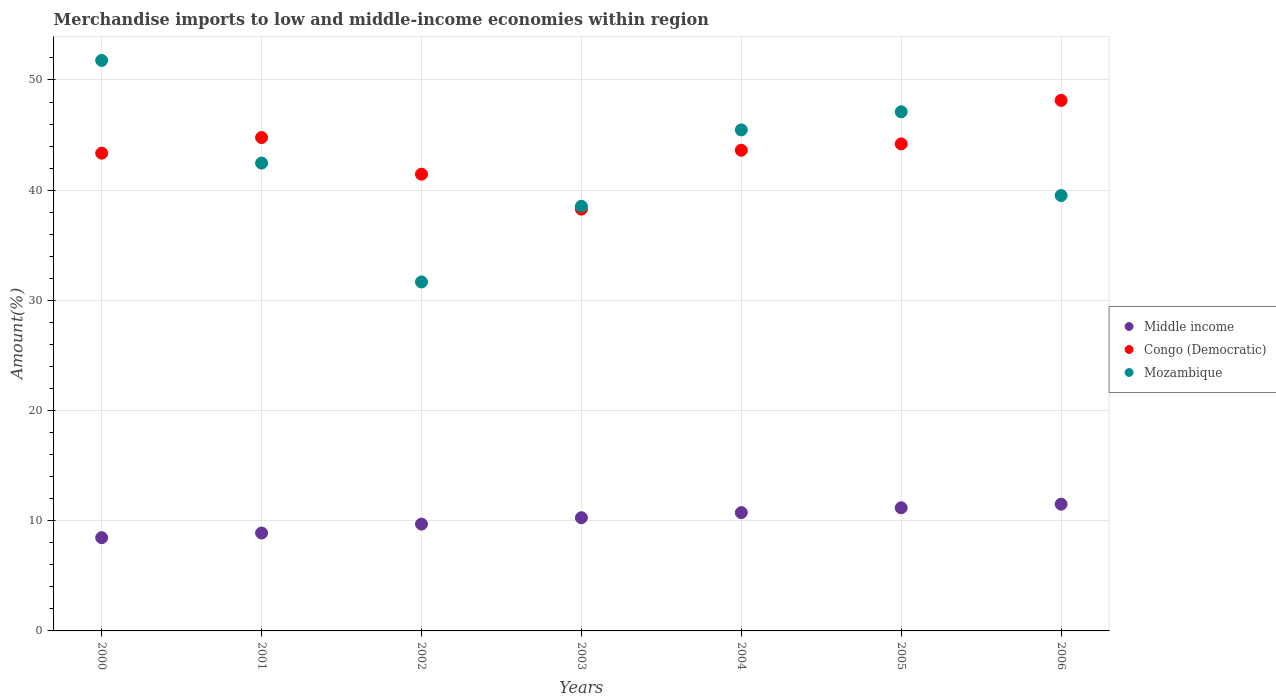How many different coloured dotlines are there?
Offer a very short reply. 3. What is the percentage of amount earned from merchandise imports in Mozambique in 2002?
Provide a short and direct response. 31.67. Across all years, what is the maximum percentage of amount earned from merchandise imports in Congo (Democratic)?
Provide a short and direct response. 48.15. Across all years, what is the minimum percentage of amount earned from merchandise imports in Mozambique?
Provide a short and direct response. 31.67. In which year was the percentage of amount earned from merchandise imports in Middle income maximum?
Give a very brief answer. 2006. In which year was the percentage of amount earned from merchandise imports in Mozambique minimum?
Ensure brevity in your answer.  2002. What is the total percentage of amount earned from merchandise imports in Mozambique in the graph?
Ensure brevity in your answer.  296.53. What is the difference between the percentage of amount earned from merchandise imports in Congo (Democratic) in 2002 and that in 2006?
Provide a short and direct response. -6.7. What is the difference between the percentage of amount earned from merchandise imports in Mozambique in 2006 and the percentage of amount earned from merchandise imports in Congo (Democratic) in 2002?
Your response must be concise. -1.94. What is the average percentage of amount earned from merchandise imports in Congo (Democratic) per year?
Keep it short and to the point. 43.4. In the year 2005, what is the difference between the percentage of amount earned from merchandise imports in Middle income and percentage of amount earned from merchandise imports in Congo (Democratic)?
Offer a terse response. -33.02. What is the ratio of the percentage of amount earned from merchandise imports in Mozambique in 2003 to that in 2005?
Offer a very short reply. 0.82. What is the difference between the highest and the second highest percentage of amount earned from merchandise imports in Mozambique?
Offer a very short reply. 4.66. What is the difference between the highest and the lowest percentage of amount earned from merchandise imports in Congo (Democratic)?
Your answer should be compact. 9.87. In how many years, is the percentage of amount earned from merchandise imports in Congo (Democratic) greater than the average percentage of amount earned from merchandise imports in Congo (Democratic) taken over all years?
Provide a succinct answer. 4. Is it the case that in every year, the sum of the percentage of amount earned from merchandise imports in Middle income and percentage of amount earned from merchandise imports in Mozambique  is greater than the percentage of amount earned from merchandise imports in Congo (Democratic)?
Give a very brief answer. No. Does the percentage of amount earned from merchandise imports in Congo (Democratic) monotonically increase over the years?
Your response must be concise. No. How many dotlines are there?
Ensure brevity in your answer.  3. Are the values on the major ticks of Y-axis written in scientific E-notation?
Keep it short and to the point. No. Does the graph contain grids?
Your response must be concise. Yes. Where does the legend appear in the graph?
Give a very brief answer. Center right. What is the title of the graph?
Your response must be concise. Merchandise imports to low and middle-income economies within region. Does "Grenada" appear as one of the legend labels in the graph?
Provide a short and direct response. No. What is the label or title of the X-axis?
Offer a very short reply. Years. What is the label or title of the Y-axis?
Your answer should be compact. Amount(%). What is the Amount(%) in Middle income in 2000?
Offer a very short reply. 8.46. What is the Amount(%) of Congo (Democratic) in 2000?
Make the answer very short. 43.36. What is the Amount(%) of Mozambique in 2000?
Offer a very short reply. 51.77. What is the Amount(%) of Middle income in 2001?
Make the answer very short. 8.89. What is the Amount(%) in Congo (Democratic) in 2001?
Your answer should be compact. 44.78. What is the Amount(%) in Mozambique in 2001?
Make the answer very short. 42.46. What is the Amount(%) of Middle income in 2002?
Keep it short and to the point. 9.69. What is the Amount(%) of Congo (Democratic) in 2002?
Provide a succinct answer. 41.45. What is the Amount(%) of Mozambique in 2002?
Offer a terse response. 31.67. What is the Amount(%) of Middle income in 2003?
Provide a short and direct response. 10.27. What is the Amount(%) of Congo (Democratic) in 2003?
Keep it short and to the point. 38.28. What is the Amount(%) in Mozambique in 2003?
Provide a short and direct response. 38.54. What is the Amount(%) in Middle income in 2004?
Provide a short and direct response. 10.74. What is the Amount(%) of Congo (Democratic) in 2004?
Your answer should be very brief. 43.62. What is the Amount(%) of Mozambique in 2004?
Ensure brevity in your answer.  45.47. What is the Amount(%) in Middle income in 2005?
Keep it short and to the point. 11.17. What is the Amount(%) of Congo (Democratic) in 2005?
Keep it short and to the point. 44.2. What is the Amount(%) of Mozambique in 2005?
Offer a terse response. 47.11. What is the Amount(%) in Middle income in 2006?
Your answer should be compact. 11.5. What is the Amount(%) in Congo (Democratic) in 2006?
Your answer should be very brief. 48.15. What is the Amount(%) in Mozambique in 2006?
Offer a very short reply. 39.51. Across all years, what is the maximum Amount(%) of Middle income?
Your answer should be very brief. 11.5. Across all years, what is the maximum Amount(%) of Congo (Democratic)?
Your response must be concise. 48.15. Across all years, what is the maximum Amount(%) of Mozambique?
Offer a very short reply. 51.77. Across all years, what is the minimum Amount(%) in Middle income?
Ensure brevity in your answer.  8.46. Across all years, what is the minimum Amount(%) in Congo (Democratic)?
Your answer should be very brief. 38.28. Across all years, what is the minimum Amount(%) in Mozambique?
Offer a terse response. 31.67. What is the total Amount(%) of Middle income in the graph?
Offer a very short reply. 70.73. What is the total Amount(%) in Congo (Democratic) in the graph?
Offer a terse response. 303.83. What is the total Amount(%) of Mozambique in the graph?
Provide a succinct answer. 296.53. What is the difference between the Amount(%) in Middle income in 2000 and that in 2001?
Your answer should be very brief. -0.42. What is the difference between the Amount(%) in Congo (Democratic) in 2000 and that in 2001?
Your response must be concise. -1.42. What is the difference between the Amount(%) in Mozambique in 2000 and that in 2001?
Offer a terse response. 9.32. What is the difference between the Amount(%) of Middle income in 2000 and that in 2002?
Your response must be concise. -1.23. What is the difference between the Amount(%) of Congo (Democratic) in 2000 and that in 2002?
Offer a terse response. 1.91. What is the difference between the Amount(%) of Mozambique in 2000 and that in 2002?
Provide a succinct answer. 20.1. What is the difference between the Amount(%) in Middle income in 2000 and that in 2003?
Offer a very short reply. -1.81. What is the difference between the Amount(%) in Congo (Democratic) in 2000 and that in 2003?
Provide a succinct answer. 5.08. What is the difference between the Amount(%) of Mozambique in 2000 and that in 2003?
Provide a short and direct response. 13.23. What is the difference between the Amount(%) in Middle income in 2000 and that in 2004?
Ensure brevity in your answer.  -2.28. What is the difference between the Amount(%) in Congo (Democratic) in 2000 and that in 2004?
Provide a short and direct response. -0.27. What is the difference between the Amount(%) of Mozambique in 2000 and that in 2004?
Your answer should be compact. 6.31. What is the difference between the Amount(%) of Middle income in 2000 and that in 2005?
Your response must be concise. -2.71. What is the difference between the Amount(%) of Congo (Democratic) in 2000 and that in 2005?
Provide a short and direct response. -0.84. What is the difference between the Amount(%) in Mozambique in 2000 and that in 2005?
Ensure brevity in your answer.  4.66. What is the difference between the Amount(%) in Middle income in 2000 and that in 2006?
Give a very brief answer. -3.04. What is the difference between the Amount(%) in Congo (Democratic) in 2000 and that in 2006?
Your response must be concise. -4.79. What is the difference between the Amount(%) in Mozambique in 2000 and that in 2006?
Offer a terse response. 12.26. What is the difference between the Amount(%) in Middle income in 2001 and that in 2002?
Your answer should be compact. -0.81. What is the difference between the Amount(%) of Congo (Democratic) in 2001 and that in 2002?
Provide a succinct answer. 3.32. What is the difference between the Amount(%) of Mozambique in 2001 and that in 2002?
Your response must be concise. 10.79. What is the difference between the Amount(%) of Middle income in 2001 and that in 2003?
Your answer should be very brief. -1.39. What is the difference between the Amount(%) in Congo (Democratic) in 2001 and that in 2003?
Give a very brief answer. 6.5. What is the difference between the Amount(%) in Mozambique in 2001 and that in 2003?
Offer a very short reply. 3.92. What is the difference between the Amount(%) of Middle income in 2001 and that in 2004?
Ensure brevity in your answer.  -1.85. What is the difference between the Amount(%) in Congo (Democratic) in 2001 and that in 2004?
Your response must be concise. 1.15. What is the difference between the Amount(%) of Mozambique in 2001 and that in 2004?
Give a very brief answer. -3.01. What is the difference between the Amount(%) in Middle income in 2001 and that in 2005?
Your answer should be compact. -2.29. What is the difference between the Amount(%) in Congo (Democratic) in 2001 and that in 2005?
Provide a succinct answer. 0.58. What is the difference between the Amount(%) in Mozambique in 2001 and that in 2005?
Ensure brevity in your answer.  -4.66. What is the difference between the Amount(%) in Middle income in 2001 and that in 2006?
Provide a short and direct response. -2.62. What is the difference between the Amount(%) of Congo (Democratic) in 2001 and that in 2006?
Offer a terse response. -3.37. What is the difference between the Amount(%) of Mozambique in 2001 and that in 2006?
Your response must be concise. 2.94. What is the difference between the Amount(%) in Middle income in 2002 and that in 2003?
Give a very brief answer. -0.58. What is the difference between the Amount(%) of Congo (Democratic) in 2002 and that in 2003?
Your response must be concise. 3.17. What is the difference between the Amount(%) in Mozambique in 2002 and that in 2003?
Your response must be concise. -6.87. What is the difference between the Amount(%) of Middle income in 2002 and that in 2004?
Ensure brevity in your answer.  -1.04. What is the difference between the Amount(%) of Congo (Democratic) in 2002 and that in 2004?
Provide a succinct answer. -2.17. What is the difference between the Amount(%) in Mozambique in 2002 and that in 2004?
Your answer should be very brief. -13.8. What is the difference between the Amount(%) in Middle income in 2002 and that in 2005?
Your response must be concise. -1.48. What is the difference between the Amount(%) in Congo (Democratic) in 2002 and that in 2005?
Offer a terse response. -2.75. What is the difference between the Amount(%) of Mozambique in 2002 and that in 2005?
Offer a very short reply. -15.44. What is the difference between the Amount(%) in Middle income in 2002 and that in 2006?
Ensure brevity in your answer.  -1.81. What is the difference between the Amount(%) in Congo (Democratic) in 2002 and that in 2006?
Keep it short and to the point. -6.7. What is the difference between the Amount(%) of Mozambique in 2002 and that in 2006?
Ensure brevity in your answer.  -7.84. What is the difference between the Amount(%) of Middle income in 2003 and that in 2004?
Provide a succinct answer. -0.46. What is the difference between the Amount(%) of Congo (Democratic) in 2003 and that in 2004?
Make the answer very short. -5.34. What is the difference between the Amount(%) in Mozambique in 2003 and that in 2004?
Offer a terse response. -6.93. What is the difference between the Amount(%) of Middle income in 2003 and that in 2005?
Make the answer very short. -0.9. What is the difference between the Amount(%) in Congo (Democratic) in 2003 and that in 2005?
Your answer should be very brief. -5.92. What is the difference between the Amount(%) of Mozambique in 2003 and that in 2005?
Your answer should be compact. -8.57. What is the difference between the Amount(%) in Middle income in 2003 and that in 2006?
Offer a very short reply. -1.23. What is the difference between the Amount(%) of Congo (Democratic) in 2003 and that in 2006?
Your answer should be compact. -9.87. What is the difference between the Amount(%) of Mozambique in 2003 and that in 2006?
Make the answer very short. -0.98. What is the difference between the Amount(%) in Middle income in 2004 and that in 2005?
Offer a very short reply. -0.44. What is the difference between the Amount(%) of Congo (Democratic) in 2004 and that in 2005?
Provide a short and direct response. -0.57. What is the difference between the Amount(%) of Mozambique in 2004 and that in 2005?
Ensure brevity in your answer.  -1.65. What is the difference between the Amount(%) in Middle income in 2004 and that in 2006?
Give a very brief answer. -0.76. What is the difference between the Amount(%) in Congo (Democratic) in 2004 and that in 2006?
Offer a terse response. -4.52. What is the difference between the Amount(%) of Mozambique in 2004 and that in 2006?
Your answer should be very brief. 5.95. What is the difference between the Amount(%) of Middle income in 2005 and that in 2006?
Provide a succinct answer. -0.33. What is the difference between the Amount(%) of Congo (Democratic) in 2005 and that in 2006?
Make the answer very short. -3.95. What is the difference between the Amount(%) of Mozambique in 2005 and that in 2006?
Your response must be concise. 7.6. What is the difference between the Amount(%) in Middle income in 2000 and the Amount(%) in Congo (Democratic) in 2001?
Provide a succinct answer. -36.31. What is the difference between the Amount(%) of Middle income in 2000 and the Amount(%) of Mozambique in 2001?
Your response must be concise. -33.99. What is the difference between the Amount(%) of Congo (Democratic) in 2000 and the Amount(%) of Mozambique in 2001?
Offer a terse response. 0.9. What is the difference between the Amount(%) in Middle income in 2000 and the Amount(%) in Congo (Democratic) in 2002?
Offer a very short reply. -32.99. What is the difference between the Amount(%) of Middle income in 2000 and the Amount(%) of Mozambique in 2002?
Ensure brevity in your answer.  -23.21. What is the difference between the Amount(%) of Congo (Democratic) in 2000 and the Amount(%) of Mozambique in 2002?
Ensure brevity in your answer.  11.69. What is the difference between the Amount(%) of Middle income in 2000 and the Amount(%) of Congo (Democratic) in 2003?
Your answer should be very brief. -29.82. What is the difference between the Amount(%) of Middle income in 2000 and the Amount(%) of Mozambique in 2003?
Make the answer very short. -30.08. What is the difference between the Amount(%) of Congo (Democratic) in 2000 and the Amount(%) of Mozambique in 2003?
Provide a succinct answer. 4.82. What is the difference between the Amount(%) in Middle income in 2000 and the Amount(%) in Congo (Democratic) in 2004?
Keep it short and to the point. -35.16. What is the difference between the Amount(%) of Middle income in 2000 and the Amount(%) of Mozambique in 2004?
Ensure brevity in your answer.  -37. What is the difference between the Amount(%) in Congo (Democratic) in 2000 and the Amount(%) in Mozambique in 2004?
Your answer should be very brief. -2.11. What is the difference between the Amount(%) of Middle income in 2000 and the Amount(%) of Congo (Democratic) in 2005?
Make the answer very short. -35.74. What is the difference between the Amount(%) of Middle income in 2000 and the Amount(%) of Mozambique in 2005?
Your answer should be very brief. -38.65. What is the difference between the Amount(%) of Congo (Democratic) in 2000 and the Amount(%) of Mozambique in 2005?
Provide a short and direct response. -3.76. What is the difference between the Amount(%) in Middle income in 2000 and the Amount(%) in Congo (Democratic) in 2006?
Ensure brevity in your answer.  -39.69. What is the difference between the Amount(%) of Middle income in 2000 and the Amount(%) of Mozambique in 2006?
Your answer should be compact. -31.05. What is the difference between the Amount(%) in Congo (Democratic) in 2000 and the Amount(%) in Mozambique in 2006?
Provide a short and direct response. 3.84. What is the difference between the Amount(%) of Middle income in 2001 and the Amount(%) of Congo (Democratic) in 2002?
Make the answer very short. -32.56. What is the difference between the Amount(%) of Middle income in 2001 and the Amount(%) of Mozambique in 2002?
Provide a short and direct response. -22.78. What is the difference between the Amount(%) in Congo (Democratic) in 2001 and the Amount(%) in Mozambique in 2002?
Your answer should be compact. 13.11. What is the difference between the Amount(%) of Middle income in 2001 and the Amount(%) of Congo (Democratic) in 2003?
Ensure brevity in your answer.  -29.39. What is the difference between the Amount(%) in Middle income in 2001 and the Amount(%) in Mozambique in 2003?
Provide a short and direct response. -29.65. What is the difference between the Amount(%) of Congo (Democratic) in 2001 and the Amount(%) of Mozambique in 2003?
Keep it short and to the point. 6.24. What is the difference between the Amount(%) of Middle income in 2001 and the Amount(%) of Congo (Democratic) in 2004?
Your answer should be very brief. -34.74. What is the difference between the Amount(%) in Middle income in 2001 and the Amount(%) in Mozambique in 2004?
Give a very brief answer. -36.58. What is the difference between the Amount(%) in Congo (Democratic) in 2001 and the Amount(%) in Mozambique in 2004?
Offer a terse response. -0.69. What is the difference between the Amount(%) of Middle income in 2001 and the Amount(%) of Congo (Democratic) in 2005?
Your response must be concise. -35.31. What is the difference between the Amount(%) in Middle income in 2001 and the Amount(%) in Mozambique in 2005?
Provide a short and direct response. -38.23. What is the difference between the Amount(%) in Congo (Democratic) in 2001 and the Amount(%) in Mozambique in 2005?
Keep it short and to the point. -2.34. What is the difference between the Amount(%) in Middle income in 2001 and the Amount(%) in Congo (Democratic) in 2006?
Offer a terse response. -39.26. What is the difference between the Amount(%) in Middle income in 2001 and the Amount(%) in Mozambique in 2006?
Offer a terse response. -30.63. What is the difference between the Amount(%) of Congo (Democratic) in 2001 and the Amount(%) of Mozambique in 2006?
Keep it short and to the point. 5.26. What is the difference between the Amount(%) in Middle income in 2002 and the Amount(%) in Congo (Democratic) in 2003?
Ensure brevity in your answer.  -28.59. What is the difference between the Amount(%) in Middle income in 2002 and the Amount(%) in Mozambique in 2003?
Provide a short and direct response. -28.84. What is the difference between the Amount(%) in Congo (Democratic) in 2002 and the Amount(%) in Mozambique in 2003?
Make the answer very short. 2.91. What is the difference between the Amount(%) of Middle income in 2002 and the Amount(%) of Congo (Democratic) in 2004?
Your answer should be very brief. -33.93. What is the difference between the Amount(%) of Middle income in 2002 and the Amount(%) of Mozambique in 2004?
Provide a succinct answer. -35.77. What is the difference between the Amount(%) of Congo (Democratic) in 2002 and the Amount(%) of Mozambique in 2004?
Your answer should be compact. -4.02. What is the difference between the Amount(%) of Middle income in 2002 and the Amount(%) of Congo (Democratic) in 2005?
Give a very brief answer. -34.5. What is the difference between the Amount(%) of Middle income in 2002 and the Amount(%) of Mozambique in 2005?
Keep it short and to the point. -37.42. What is the difference between the Amount(%) of Congo (Democratic) in 2002 and the Amount(%) of Mozambique in 2005?
Provide a succinct answer. -5.66. What is the difference between the Amount(%) in Middle income in 2002 and the Amount(%) in Congo (Democratic) in 2006?
Provide a short and direct response. -38.45. What is the difference between the Amount(%) in Middle income in 2002 and the Amount(%) in Mozambique in 2006?
Your answer should be very brief. -29.82. What is the difference between the Amount(%) in Congo (Democratic) in 2002 and the Amount(%) in Mozambique in 2006?
Give a very brief answer. 1.94. What is the difference between the Amount(%) in Middle income in 2003 and the Amount(%) in Congo (Democratic) in 2004?
Give a very brief answer. -33.35. What is the difference between the Amount(%) in Middle income in 2003 and the Amount(%) in Mozambique in 2004?
Provide a short and direct response. -35.19. What is the difference between the Amount(%) in Congo (Democratic) in 2003 and the Amount(%) in Mozambique in 2004?
Offer a very short reply. -7.19. What is the difference between the Amount(%) in Middle income in 2003 and the Amount(%) in Congo (Democratic) in 2005?
Your answer should be very brief. -33.92. What is the difference between the Amount(%) in Middle income in 2003 and the Amount(%) in Mozambique in 2005?
Your answer should be very brief. -36.84. What is the difference between the Amount(%) of Congo (Democratic) in 2003 and the Amount(%) of Mozambique in 2005?
Keep it short and to the point. -8.83. What is the difference between the Amount(%) in Middle income in 2003 and the Amount(%) in Congo (Democratic) in 2006?
Offer a very short reply. -37.87. What is the difference between the Amount(%) of Middle income in 2003 and the Amount(%) of Mozambique in 2006?
Your answer should be compact. -29.24. What is the difference between the Amount(%) of Congo (Democratic) in 2003 and the Amount(%) of Mozambique in 2006?
Provide a succinct answer. -1.23. What is the difference between the Amount(%) in Middle income in 2004 and the Amount(%) in Congo (Democratic) in 2005?
Your answer should be very brief. -33.46. What is the difference between the Amount(%) of Middle income in 2004 and the Amount(%) of Mozambique in 2005?
Provide a succinct answer. -36.37. What is the difference between the Amount(%) in Congo (Democratic) in 2004 and the Amount(%) in Mozambique in 2005?
Provide a short and direct response. -3.49. What is the difference between the Amount(%) of Middle income in 2004 and the Amount(%) of Congo (Democratic) in 2006?
Make the answer very short. -37.41. What is the difference between the Amount(%) in Middle income in 2004 and the Amount(%) in Mozambique in 2006?
Keep it short and to the point. -28.78. What is the difference between the Amount(%) in Congo (Democratic) in 2004 and the Amount(%) in Mozambique in 2006?
Your response must be concise. 4.11. What is the difference between the Amount(%) of Middle income in 2005 and the Amount(%) of Congo (Democratic) in 2006?
Offer a terse response. -36.97. What is the difference between the Amount(%) of Middle income in 2005 and the Amount(%) of Mozambique in 2006?
Your answer should be compact. -28.34. What is the difference between the Amount(%) of Congo (Democratic) in 2005 and the Amount(%) of Mozambique in 2006?
Make the answer very short. 4.68. What is the average Amount(%) of Middle income per year?
Offer a very short reply. 10.1. What is the average Amount(%) of Congo (Democratic) per year?
Your answer should be compact. 43.4. What is the average Amount(%) in Mozambique per year?
Keep it short and to the point. 42.36. In the year 2000, what is the difference between the Amount(%) in Middle income and Amount(%) in Congo (Democratic)?
Provide a short and direct response. -34.9. In the year 2000, what is the difference between the Amount(%) in Middle income and Amount(%) in Mozambique?
Make the answer very short. -43.31. In the year 2000, what is the difference between the Amount(%) of Congo (Democratic) and Amount(%) of Mozambique?
Provide a succinct answer. -8.42. In the year 2001, what is the difference between the Amount(%) of Middle income and Amount(%) of Congo (Democratic)?
Ensure brevity in your answer.  -35.89. In the year 2001, what is the difference between the Amount(%) in Middle income and Amount(%) in Mozambique?
Give a very brief answer. -33.57. In the year 2001, what is the difference between the Amount(%) in Congo (Democratic) and Amount(%) in Mozambique?
Provide a succinct answer. 2.32. In the year 2002, what is the difference between the Amount(%) of Middle income and Amount(%) of Congo (Democratic)?
Your answer should be very brief. -31.76. In the year 2002, what is the difference between the Amount(%) of Middle income and Amount(%) of Mozambique?
Offer a terse response. -21.98. In the year 2002, what is the difference between the Amount(%) of Congo (Democratic) and Amount(%) of Mozambique?
Your response must be concise. 9.78. In the year 2003, what is the difference between the Amount(%) in Middle income and Amount(%) in Congo (Democratic)?
Offer a very short reply. -28.01. In the year 2003, what is the difference between the Amount(%) of Middle income and Amount(%) of Mozambique?
Keep it short and to the point. -28.26. In the year 2003, what is the difference between the Amount(%) of Congo (Democratic) and Amount(%) of Mozambique?
Offer a terse response. -0.26. In the year 2004, what is the difference between the Amount(%) of Middle income and Amount(%) of Congo (Democratic)?
Your answer should be very brief. -32.88. In the year 2004, what is the difference between the Amount(%) of Middle income and Amount(%) of Mozambique?
Provide a short and direct response. -34.73. In the year 2004, what is the difference between the Amount(%) of Congo (Democratic) and Amount(%) of Mozambique?
Provide a short and direct response. -1.84. In the year 2005, what is the difference between the Amount(%) of Middle income and Amount(%) of Congo (Democratic)?
Offer a very short reply. -33.02. In the year 2005, what is the difference between the Amount(%) of Middle income and Amount(%) of Mozambique?
Provide a short and direct response. -35.94. In the year 2005, what is the difference between the Amount(%) of Congo (Democratic) and Amount(%) of Mozambique?
Your response must be concise. -2.91. In the year 2006, what is the difference between the Amount(%) in Middle income and Amount(%) in Congo (Democratic)?
Offer a terse response. -36.65. In the year 2006, what is the difference between the Amount(%) of Middle income and Amount(%) of Mozambique?
Provide a succinct answer. -28.01. In the year 2006, what is the difference between the Amount(%) of Congo (Democratic) and Amount(%) of Mozambique?
Offer a very short reply. 8.63. What is the ratio of the Amount(%) of Middle income in 2000 to that in 2001?
Your response must be concise. 0.95. What is the ratio of the Amount(%) in Congo (Democratic) in 2000 to that in 2001?
Offer a very short reply. 0.97. What is the ratio of the Amount(%) of Mozambique in 2000 to that in 2001?
Make the answer very short. 1.22. What is the ratio of the Amount(%) of Middle income in 2000 to that in 2002?
Offer a very short reply. 0.87. What is the ratio of the Amount(%) in Congo (Democratic) in 2000 to that in 2002?
Provide a succinct answer. 1.05. What is the ratio of the Amount(%) of Mozambique in 2000 to that in 2002?
Offer a very short reply. 1.63. What is the ratio of the Amount(%) in Middle income in 2000 to that in 2003?
Give a very brief answer. 0.82. What is the ratio of the Amount(%) in Congo (Democratic) in 2000 to that in 2003?
Your answer should be compact. 1.13. What is the ratio of the Amount(%) of Mozambique in 2000 to that in 2003?
Provide a succinct answer. 1.34. What is the ratio of the Amount(%) of Middle income in 2000 to that in 2004?
Offer a very short reply. 0.79. What is the ratio of the Amount(%) in Congo (Democratic) in 2000 to that in 2004?
Provide a short and direct response. 0.99. What is the ratio of the Amount(%) in Mozambique in 2000 to that in 2004?
Provide a succinct answer. 1.14. What is the ratio of the Amount(%) in Middle income in 2000 to that in 2005?
Your answer should be compact. 0.76. What is the ratio of the Amount(%) in Mozambique in 2000 to that in 2005?
Offer a very short reply. 1.1. What is the ratio of the Amount(%) of Middle income in 2000 to that in 2006?
Offer a very short reply. 0.74. What is the ratio of the Amount(%) of Congo (Democratic) in 2000 to that in 2006?
Your answer should be very brief. 0.9. What is the ratio of the Amount(%) in Mozambique in 2000 to that in 2006?
Make the answer very short. 1.31. What is the ratio of the Amount(%) in Congo (Democratic) in 2001 to that in 2002?
Keep it short and to the point. 1.08. What is the ratio of the Amount(%) of Mozambique in 2001 to that in 2002?
Offer a terse response. 1.34. What is the ratio of the Amount(%) in Middle income in 2001 to that in 2003?
Your answer should be very brief. 0.86. What is the ratio of the Amount(%) in Congo (Democratic) in 2001 to that in 2003?
Keep it short and to the point. 1.17. What is the ratio of the Amount(%) in Mozambique in 2001 to that in 2003?
Your answer should be very brief. 1.1. What is the ratio of the Amount(%) of Middle income in 2001 to that in 2004?
Your answer should be compact. 0.83. What is the ratio of the Amount(%) in Congo (Democratic) in 2001 to that in 2004?
Ensure brevity in your answer.  1.03. What is the ratio of the Amount(%) of Mozambique in 2001 to that in 2004?
Your response must be concise. 0.93. What is the ratio of the Amount(%) of Middle income in 2001 to that in 2005?
Ensure brevity in your answer.  0.8. What is the ratio of the Amount(%) of Congo (Democratic) in 2001 to that in 2005?
Provide a succinct answer. 1.01. What is the ratio of the Amount(%) in Mozambique in 2001 to that in 2005?
Offer a very short reply. 0.9. What is the ratio of the Amount(%) in Middle income in 2001 to that in 2006?
Make the answer very short. 0.77. What is the ratio of the Amount(%) of Congo (Democratic) in 2001 to that in 2006?
Provide a succinct answer. 0.93. What is the ratio of the Amount(%) of Mozambique in 2001 to that in 2006?
Make the answer very short. 1.07. What is the ratio of the Amount(%) in Middle income in 2002 to that in 2003?
Ensure brevity in your answer.  0.94. What is the ratio of the Amount(%) in Congo (Democratic) in 2002 to that in 2003?
Your answer should be compact. 1.08. What is the ratio of the Amount(%) of Mozambique in 2002 to that in 2003?
Provide a short and direct response. 0.82. What is the ratio of the Amount(%) in Middle income in 2002 to that in 2004?
Ensure brevity in your answer.  0.9. What is the ratio of the Amount(%) in Congo (Democratic) in 2002 to that in 2004?
Ensure brevity in your answer.  0.95. What is the ratio of the Amount(%) of Mozambique in 2002 to that in 2004?
Give a very brief answer. 0.7. What is the ratio of the Amount(%) in Middle income in 2002 to that in 2005?
Ensure brevity in your answer.  0.87. What is the ratio of the Amount(%) in Congo (Democratic) in 2002 to that in 2005?
Provide a short and direct response. 0.94. What is the ratio of the Amount(%) of Mozambique in 2002 to that in 2005?
Keep it short and to the point. 0.67. What is the ratio of the Amount(%) in Middle income in 2002 to that in 2006?
Make the answer very short. 0.84. What is the ratio of the Amount(%) of Congo (Democratic) in 2002 to that in 2006?
Your response must be concise. 0.86. What is the ratio of the Amount(%) in Mozambique in 2002 to that in 2006?
Your response must be concise. 0.8. What is the ratio of the Amount(%) of Middle income in 2003 to that in 2004?
Offer a very short reply. 0.96. What is the ratio of the Amount(%) in Congo (Democratic) in 2003 to that in 2004?
Offer a terse response. 0.88. What is the ratio of the Amount(%) in Mozambique in 2003 to that in 2004?
Your response must be concise. 0.85. What is the ratio of the Amount(%) of Middle income in 2003 to that in 2005?
Provide a succinct answer. 0.92. What is the ratio of the Amount(%) of Congo (Democratic) in 2003 to that in 2005?
Your response must be concise. 0.87. What is the ratio of the Amount(%) of Mozambique in 2003 to that in 2005?
Offer a very short reply. 0.82. What is the ratio of the Amount(%) of Middle income in 2003 to that in 2006?
Provide a succinct answer. 0.89. What is the ratio of the Amount(%) of Congo (Democratic) in 2003 to that in 2006?
Provide a short and direct response. 0.8. What is the ratio of the Amount(%) in Mozambique in 2003 to that in 2006?
Offer a very short reply. 0.98. What is the ratio of the Amount(%) of Congo (Democratic) in 2004 to that in 2005?
Your answer should be very brief. 0.99. What is the ratio of the Amount(%) of Mozambique in 2004 to that in 2005?
Ensure brevity in your answer.  0.97. What is the ratio of the Amount(%) of Middle income in 2004 to that in 2006?
Your response must be concise. 0.93. What is the ratio of the Amount(%) in Congo (Democratic) in 2004 to that in 2006?
Your answer should be very brief. 0.91. What is the ratio of the Amount(%) of Mozambique in 2004 to that in 2006?
Provide a succinct answer. 1.15. What is the ratio of the Amount(%) of Middle income in 2005 to that in 2006?
Make the answer very short. 0.97. What is the ratio of the Amount(%) in Congo (Democratic) in 2005 to that in 2006?
Provide a short and direct response. 0.92. What is the ratio of the Amount(%) of Mozambique in 2005 to that in 2006?
Make the answer very short. 1.19. What is the difference between the highest and the second highest Amount(%) in Middle income?
Offer a very short reply. 0.33. What is the difference between the highest and the second highest Amount(%) in Congo (Democratic)?
Offer a terse response. 3.37. What is the difference between the highest and the second highest Amount(%) of Mozambique?
Ensure brevity in your answer.  4.66. What is the difference between the highest and the lowest Amount(%) in Middle income?
Keep it short and to the point. 3.04. What is the difference between the highest and the lowest Amount(%) of Congo (Democratic)?
Provide a short and direct response. 9.87. What is the difference between the highest and the lowest Amount(%) of Mozambique?
Offer a terse response. 20.1. 